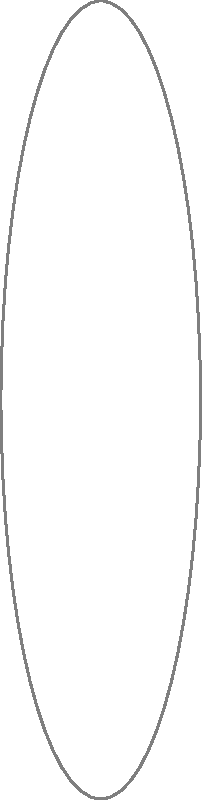Analyze the scatter plot showing the relationship between age groups and privacy concern levels. What type of correlation does the data suggest, and how might this information be valuable for a marketing strategy targeting different age demographics? To analyze the correlation between age groups and privacy concerns:

1. Observe the overall trend: As age increases, privacy concern levels also increase.

2. Identify the correlation type:
   - Points move from bottom-left to top-right
   - Consistent upward trend
   This indicates a positive correlation.

3. Assess the strength:
   - Points form a relatively straight line
   - Limited scatter around the trend
   This suggests a strong positive correlation.

4. Quantify the relationship:
   - Youngest age group (20) has lowest concern (3)
   - Oldest age group (70) has highest concern (9)
   - Consistent increase across age groups

5. Marketing strategy implications:
   a) Younger demographics (20-40):
      - Lower privacy concerns
      - May be more open to data-driven marketing
      - Focus on benefits of personalization

   b) Middle-aged demographics (40-60):
      - Moderate to high privacy concerns
      - Balance personalization with transparency
      - Emphasize data protection measures

   c) Older demographics (60+):
      - Highest privacy concerns
      - Prioritize privacy and security in messaging
      - Offer more control over data sharing

6. Overall strategy:
   - Tailor privacy-related messaging to each age group
   - Develop age-specific data collection and usage policies
   - Create targeted educational content about data privacy
Answer: Strong positive correlation; tailor privacy messaging and data practices by age group. 